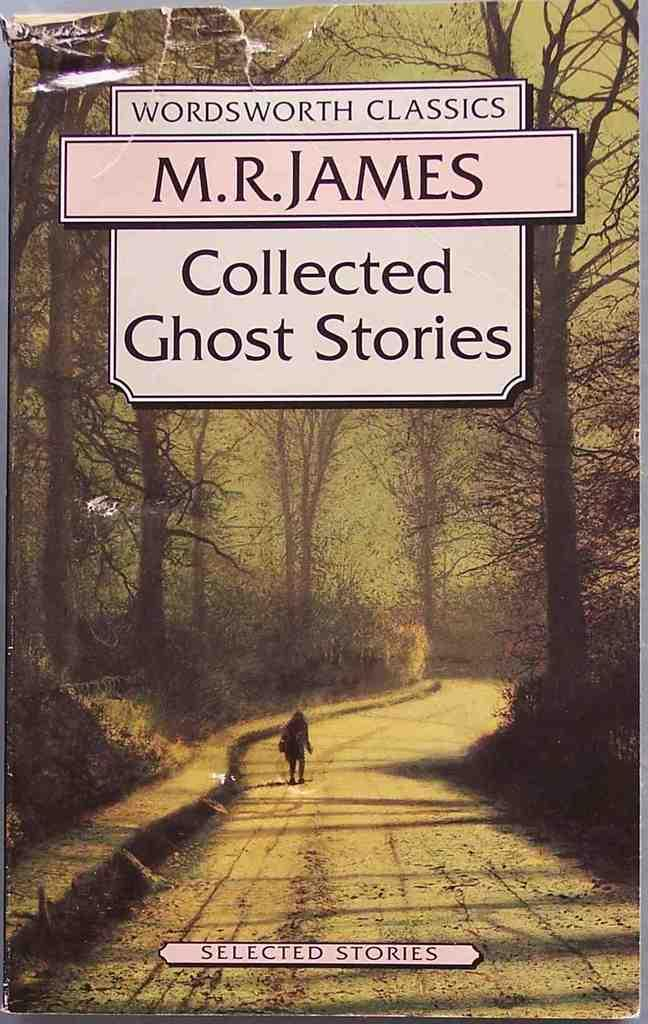What is featured in the image? There is a poster, a walking path, a person standing, trees, and text in the image. Can you describe the walking path in the image? The walking path is at the bottom of the image. What is the person standing doing in the image? The person's actions are not specified, but they are standing in the image. What type of vegetation is present in the image? There are trees in the image. What else can be seen in the image besides the person and the trees? There is a poster and text in the image. What type of cap is the servant wearing in the image? There is no servant or cap present in the image. What observation can be made about the person's behavior in the image? The person's behavior is not specified in the image, so no observation can be made. 